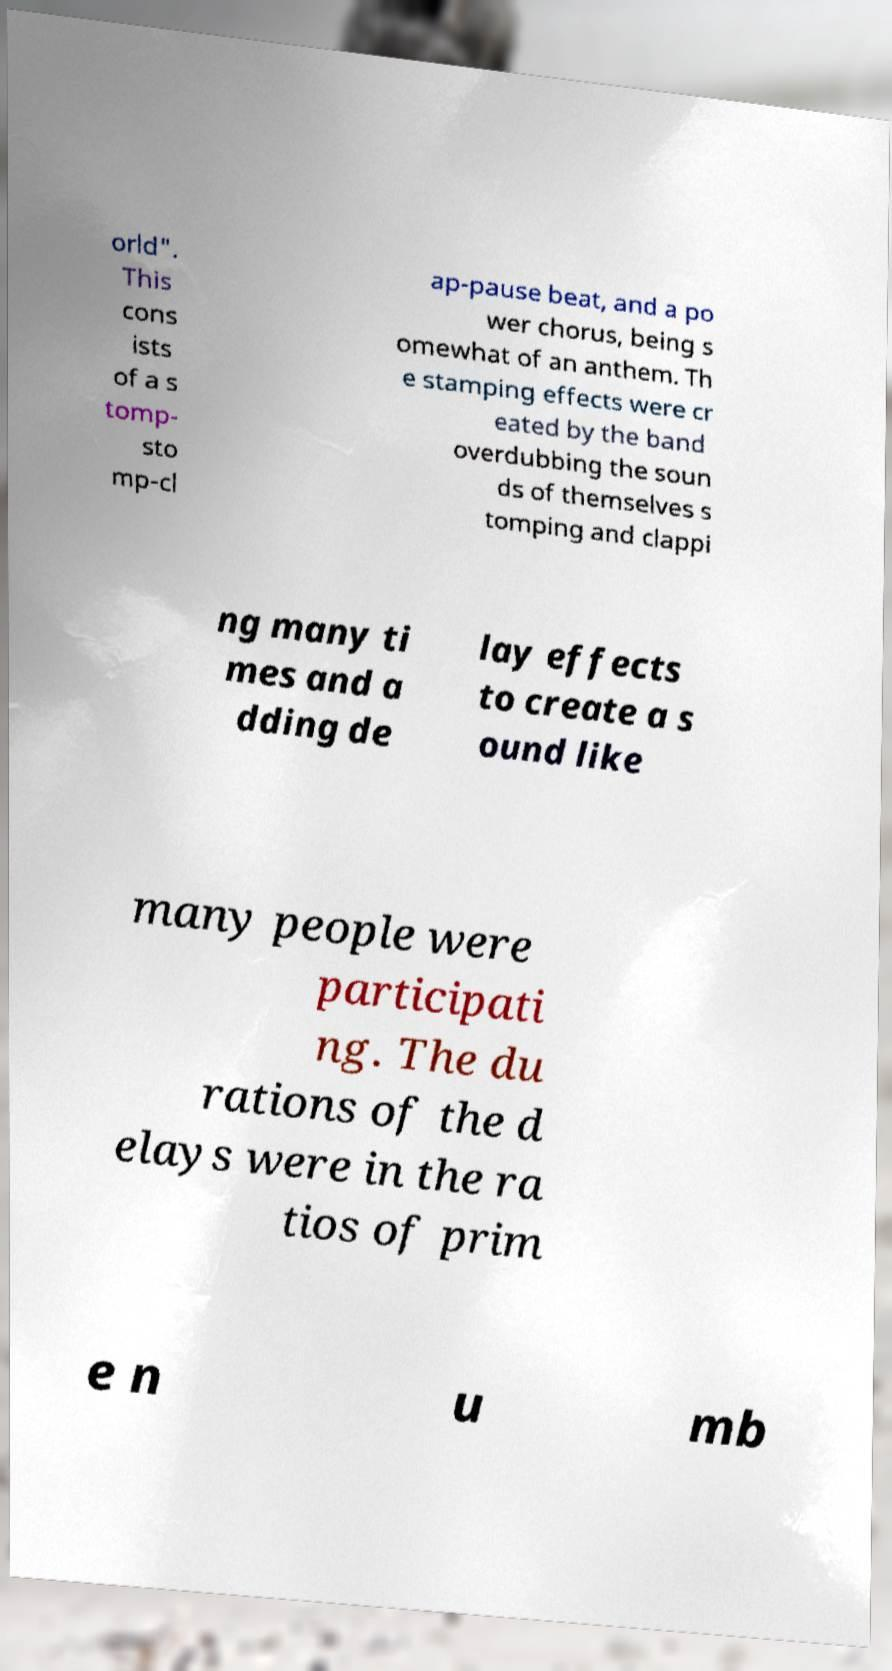Please identify and transcribe the text found in this image. orld". This cons ists of a s tomp- sto mp-cl ap-pause beat, and a po wer chorus, being s omewhat of an anthem. Th e stamping effects were cr eated by the band overdubbing the soun ds of themselves s tomping and clappi ng many ti mes and a dding de lay effects to create a s ound like many people were participati ng. The du rations of the d elays were in the ra tios of prim e n u mb 